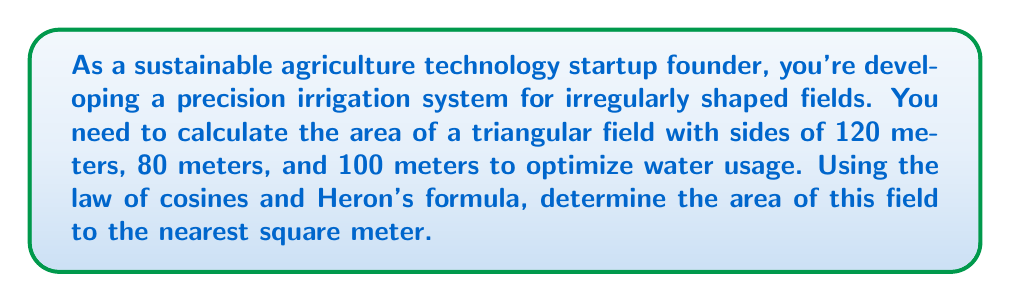Solve this math problem. Let's approach this step-by-step:

1) First, we need to find one of the angles of the triangle using the law of cosines. Let's choose the angle opposite the 100m side. We'll call this angle $\theta$.

   $$\cos \theta = \frac{a^2 + b^2 - c^2}{2ab}$$

   Where $a = 120$, $b = 80$, and $c = 100$

2) Plugging in the values:

   $$\cos \theta = \frac{120^2 + 80^2 - 100^2}{2(120)(80)}$$

3) Simplify:

   $$\cos \theta = \frac{14400 + 6400 - 10000}{19200} = \frac{10800}{19200} = 0.5625$$

4) To find $\theta$, we take the inverse cosine:

   $$\theta = \arccos(0.5625) \approx 0.9775 \text{ radians} \approx 56.02°$$

5) Now that we have an angle, we could use the sine formula to find the area. However, we can also use Heron's formula, which doesn't require knowing any angles:

   $$A = \sqrt{s(s-a)(s-b)(s-c)}$$

   Where $s$ is the semi-perimeter: $s = \frac{a+b+c}{2}$

6) Calculate $s$:

   $$s = \frac{120 + 80 + 100}{2} = 150$$

7) Now apply Heron's formula:

   $$A = \sqrt{150(150-120)(150-80)(150-100)}$$

8) Simplify:

   $$A = \sqrt{150 \cdot 30 \cdot 70 \cdot 50} = \sqrt{15,750,000} \approx 3,968.63$$

9) Rounding to the nearest square meter:

   $$A \approx 3,969 \text{ m}^2$$
Answer: 3,969 m² 